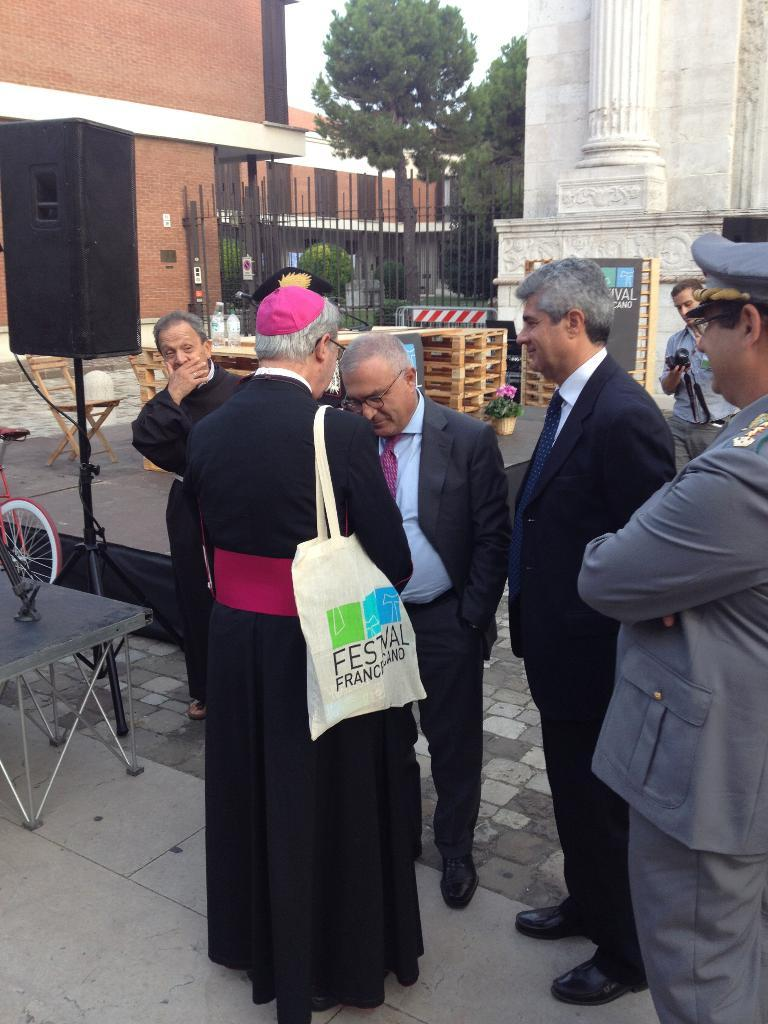How many people can be seen in the image? There are people standing in the image. What is one piece of furniture present in the image? There is a table in the image. What type of object is circular and has spokes in the image? There is a wheel in the image. What device might be used for amplifying sound in the image? There is a speaker in the image. What type of seating is available in the image? There is a chair in the image. What type of living organisms can be seen in the image? There are plants in the image. What type of barrier can be seen in the image? There is a fence in the image. What type of tall vegetation can be seen in the image? There are trees in the image. What type of structure can be seen in the image that provides support and stability? There is a pillar in the image. What part of the natural environment is visible in the image? The sky is visible in the image. What other objects can be seen in the image? There are other objects in the image. Can you tell me how many hills are visible in the image? There are no hills visible in the image. What type of music is being played in the image? There is no music being played in the image. 